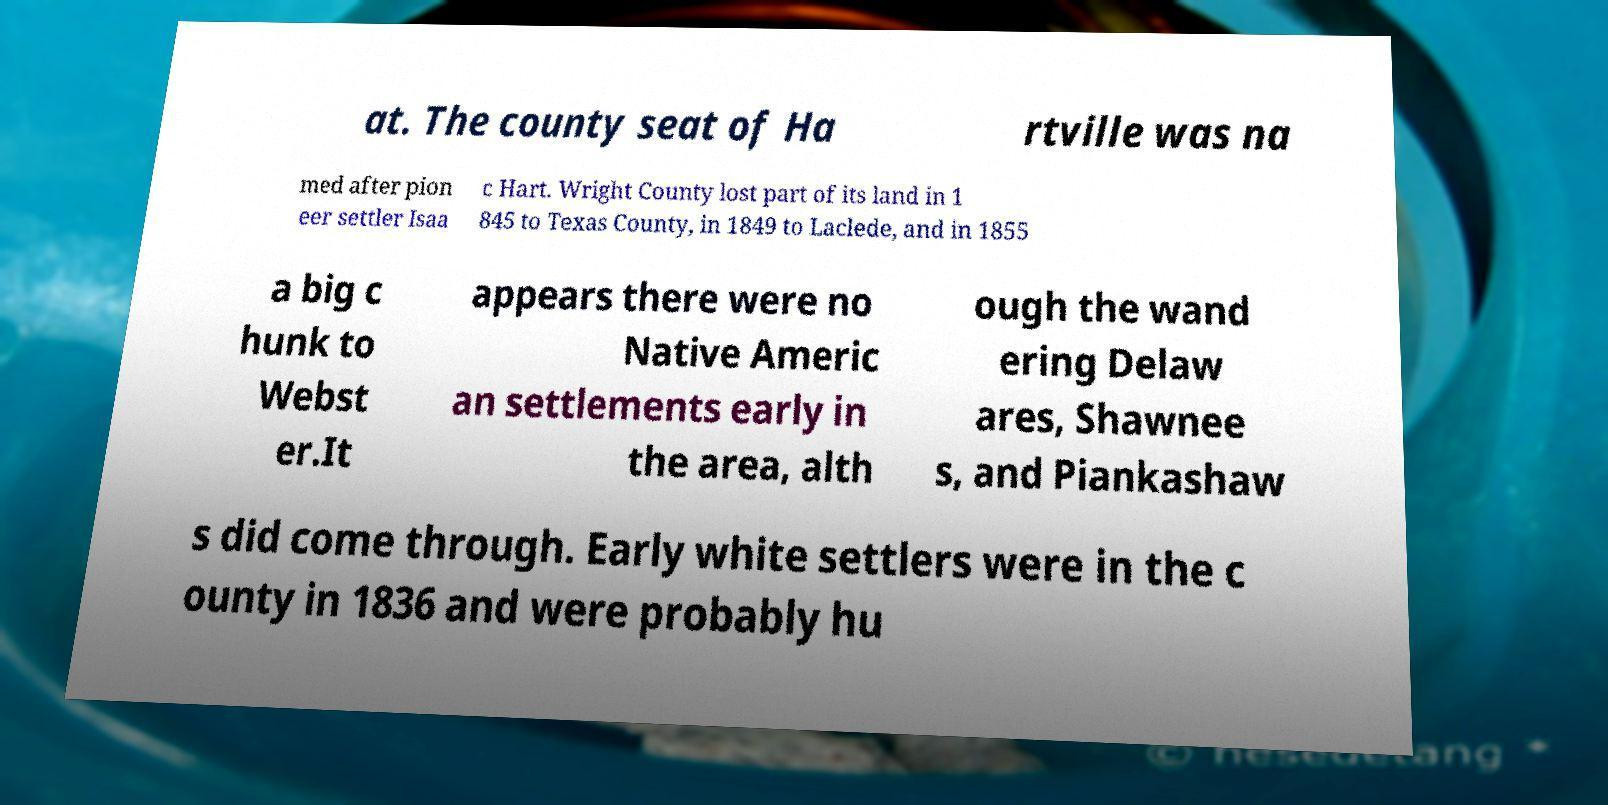Please read and relay the text visible in this image. What does it say? at. The county seat of Ha rtville was na med after pion eer settler Isaa c Hart. Wright County lost part of its land in 1 845 to Texas County, in 1849 to Laclede, and in 1855 a big c hunk to Webst er.It appears there were no Native Americ an settlements early in the area, alth ough the wand ering Delaw ares, Shawnee s, and Piankashaw s did come through. Early white settlers were in the c ounty in 1836 and were probably hu 